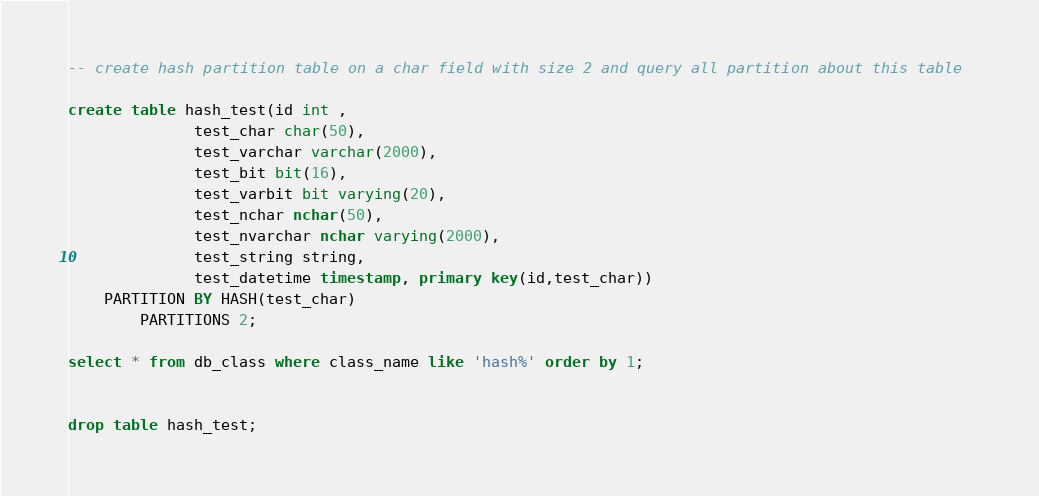Convert code to text. <code><loc_0><loc_0><loc_500><loc_500><_SQL_>-- create hash partition table on a char field with size 2 and query all partition about this table  

create table hash_test(id int ,
			  test_char char(50),
			  test_varchar varchar(2000),
			  test_bit bit(16),
			  test_varbit bit varying(20),
			  test_nchar nchar(50),
			  test_nvarchar nchar varying(2000),
			  test_string string,
			  test_datetime timestamp, primary key(id,test_char))
	PARTITION BY HASH(test_char)
        PARTITIONS 2;

select * from db_class where class_name like 'hash%' order by 1;


drop table hash_test;</code> 